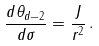Convert formula to latex. <formula><loc_0><loc_0><loc_500><loc_500>\frac { d \theta _ { d - 2 } } { d \sigma } = \frac { J } { r ^ { 2 } } \, .</formula> 